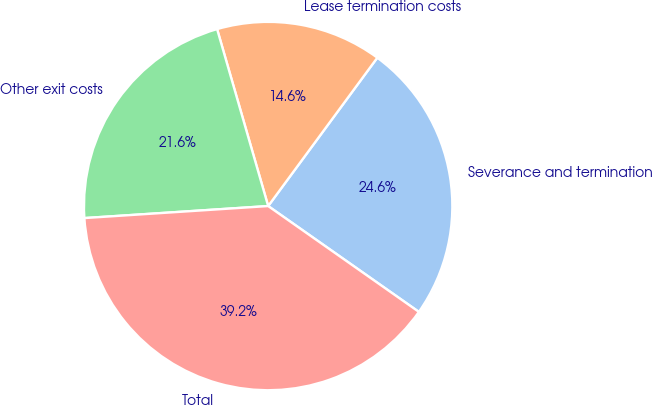Convert chart. <chart><loc_0><loc_0><loc_500><loc_500><pie_chart><fcel>Severance and termination<fcel>Lease termination costs<fcel>Other exit costs<fcel>Total<nl><fcel>24.65%<fcel>14.57%<fcel>21.57%<fcel>39.22%<nl></chart> 